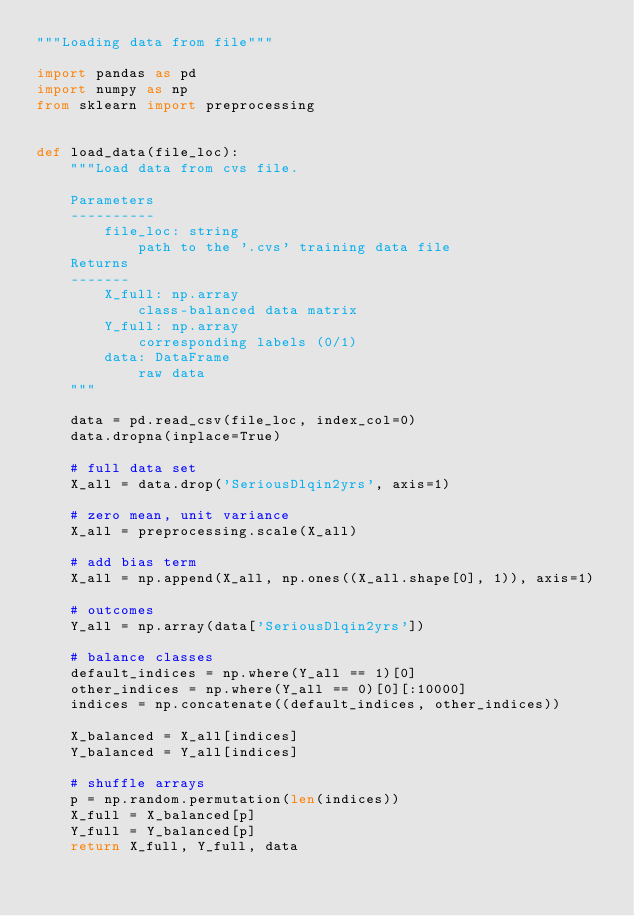Convert code to text. <code><loc_0><loc_0><loc_500><loc_500><_Python_>"""Loading data from file"""

import pandas as pd
import numpy as np
from sklearn import preprocessing


def load_data(file_loc):
    """Load data from cvs file.

    Parameters
    ----------
        file_loc: string
            path to the '.cvs' training data file
    Returns
    -------
        X_full: np.array
            class-balanced data matrix     
        Y_full: np.array
            corresponding labels (0/1) 
        data: DataFrame
            raw data     
    """

    data = pd.read_csv(file_loc, index_col=0)
    data.dropna(inplace=True)

    # full data set
    X_all = data.drop('SeriousDlqin2yrs', axis=1)

    # zero mean, unit variance
    X_all = preprocessing.scale(X_all)

    # add bias term
    X_all = np.append(X_all, np.ones((X_all.shape[0], 1)), axis=1)

    # outcomes
    Y_all = np.array(data['SeriousDlqin2yrs'])

    # balance classes
    default_indices = np.where(Y_all == 1)[0]
    other_indices = np.where(Y_all == 0)[0][:10000]
    indices = np.concatenate((default_indices, other_indices))

    X_balanced = X_all[indices]
    Y_balanced = Y_all[indices]

    # shuffle arrays
    p = np.random.permutation(len(indices))
    X_full = X_balanced[p]
    Y_full = Y_balanced[p]
    return X_full, Y_full, data
</code> 